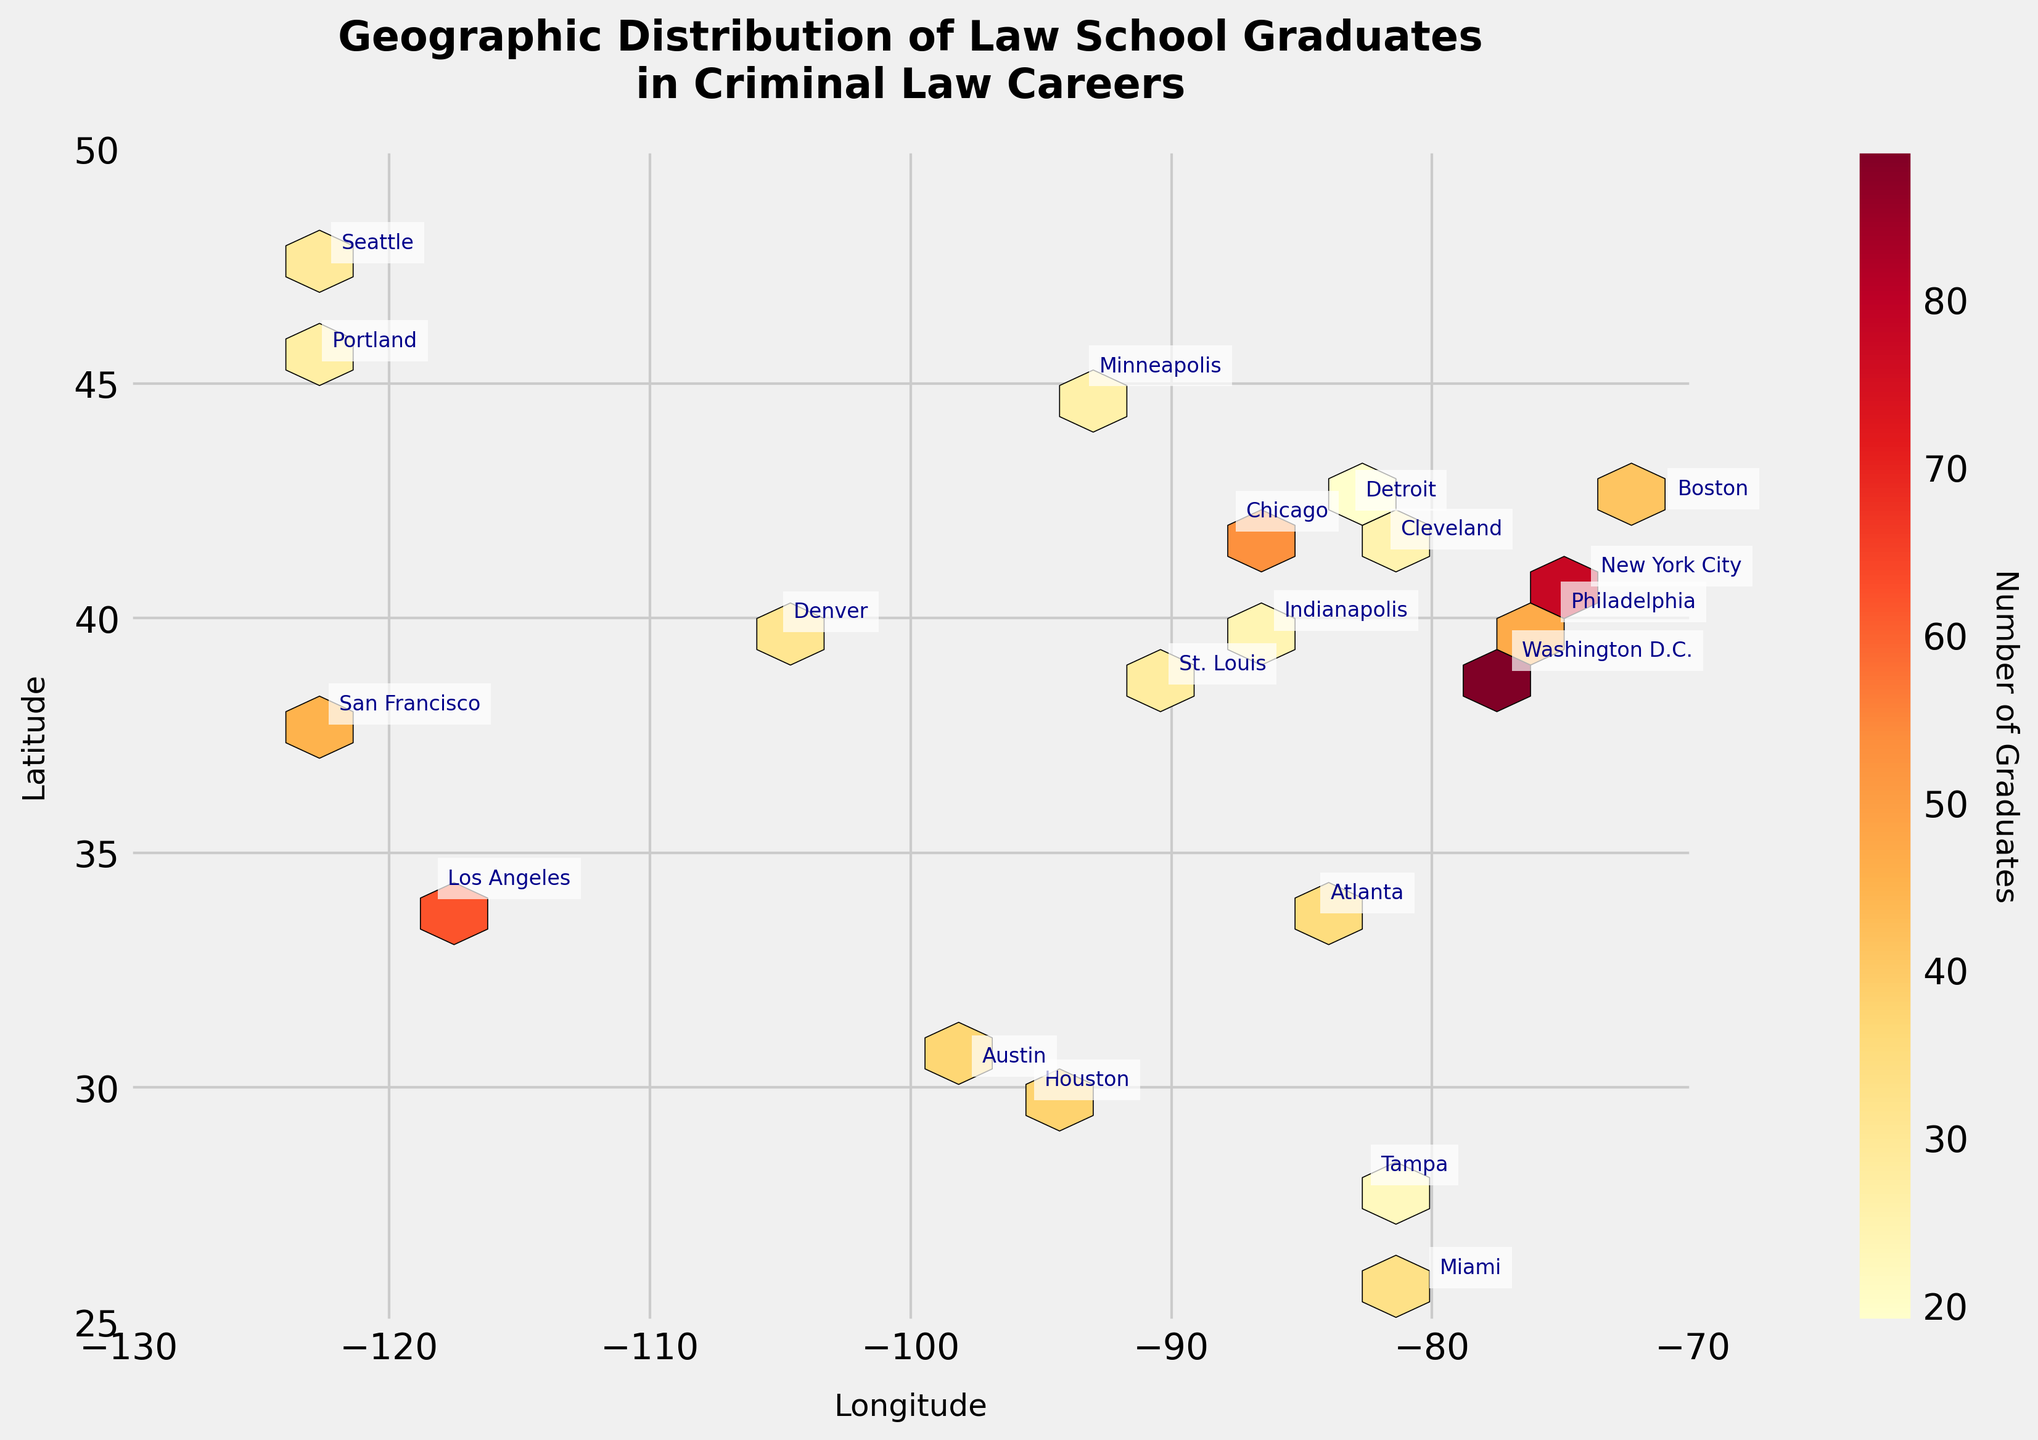what is the title of the plot? The title is written at the top of the plot. It reads, "Geographic Distribution of Law School Graduates in Criminal Law Careers," indicating the focus on the distribution of law graduates in careers within criminal law.
Answer: Geographic Distribution of Law School Graduates in Criminal Law Careers what do the x-axis and y-axis represent? The x-axis is labeled "Longitude" and the y-axis is labeled "Latitude." These labels indicate that the plot is mapping the geographic locations of law graduates.
Answer: Longitude and Latitude which region has the highest number of graduates? By examining the color intensity and any annotations, Washington D.C. is marked with 89 graduates, the highest among all listed regions.
Answer: Washington D.C compare the number of graduates in Los Angeles and New York City. Which city has more? By referring to the annotations next to both locations, Los Angeles has 62 graduates and New York City has 78 graduates. New York City has more graduates.
Answer: New York City which regions have a number of graduates greater than 40 but less than 60? By checking the annotations, the regions with graduate counts between 40 and 60 are San Francisco (45), Chicago (53), and Boston (41).
Answer: San Francisco, Chicago, Boston what is the color scheme used in the hexbin plot? The color scheme is a gradient ranging from lighter to darker shades of yellow, orange, and red, representing increasing numbers of graduates.
Answer: Shades of yellow, orange, and red what does the color intensity indicate in the hexbin plot? The legend and color bar show that lighter colors represent fewer graduates, while darker colors indicate a higher number of graduates.
Answer: Number of graduates which regions have the lowest number of graduates? By looking at the regions with lighter colors and examining annotations, Detroit (19) and Tampa (22) have among the lowest numbers of graduates.
Answer: Detroit, Tampa identify the regions located within the latitude range of 25 to 30 degrees. By checking the y-axis and annotations, Houston (29.7604), Miami (25.7617), and Tampa (27.9506) fall within this latitude range.
Answer: Houston, Miami, Tampa is there a region that shares a similar number of graduates with Denver? If yes, which one? Denver has 31 graduates. By comparing the annotations, Portland, which has 27 graduates, is quite close to Denver's number.
Answer: Portland 